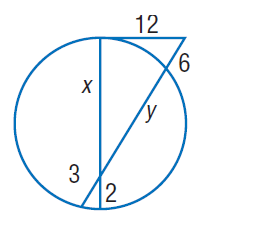Answer the mathemtical geometry problem and directly provide the correct option letter.
Question: Find x. Round to the nearest tenth, if necessary.
Choices: A: 2 B: 6 C: 12 D: 15 D 